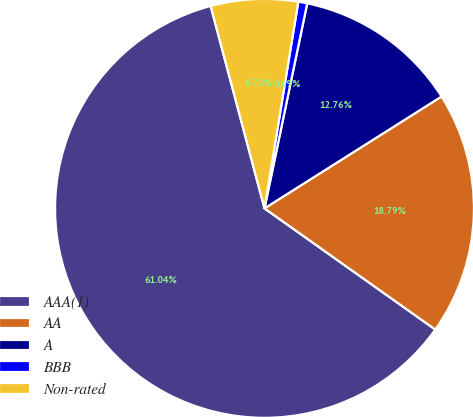Convert chart to OTSL. <chart><loc_0><loc_0><loc_500><loc_500><pie_chart><fcel>AAA(1)<fcel>AA<fcel>A<fcel>BBB<fcel>Non-rated<nl><fcel>61.04%<fcel>18.79%<fcel>12.76%<fcel>0.69%<fcel>6.72%<nl></chart> 